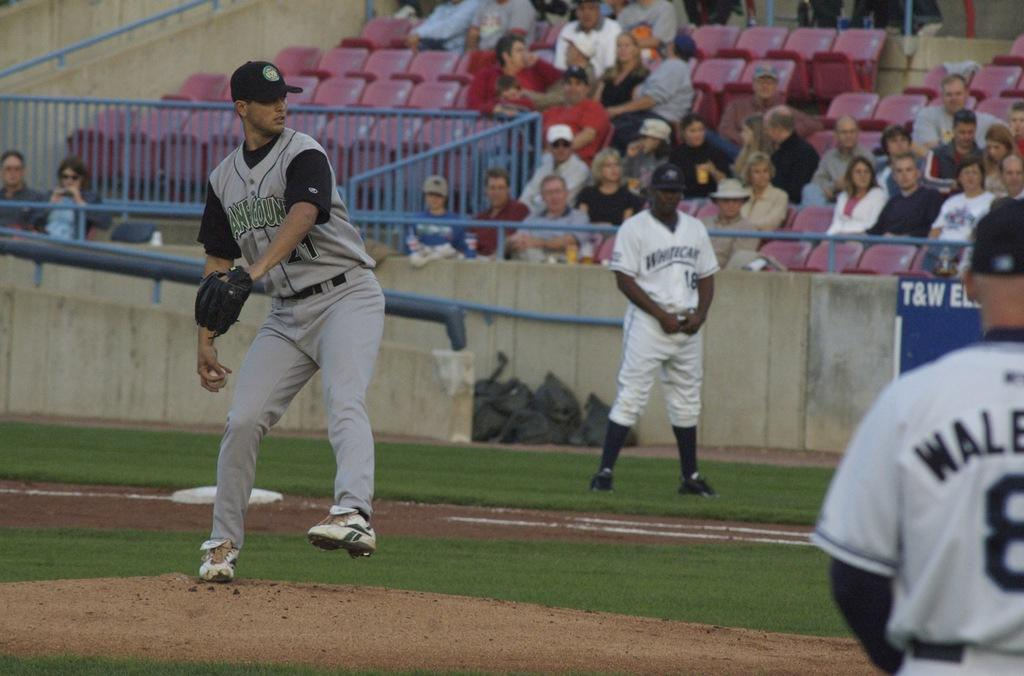<image>
Provide a brief description of the given image. Baseball pitcher with the number 21 ready to throw the ball. 